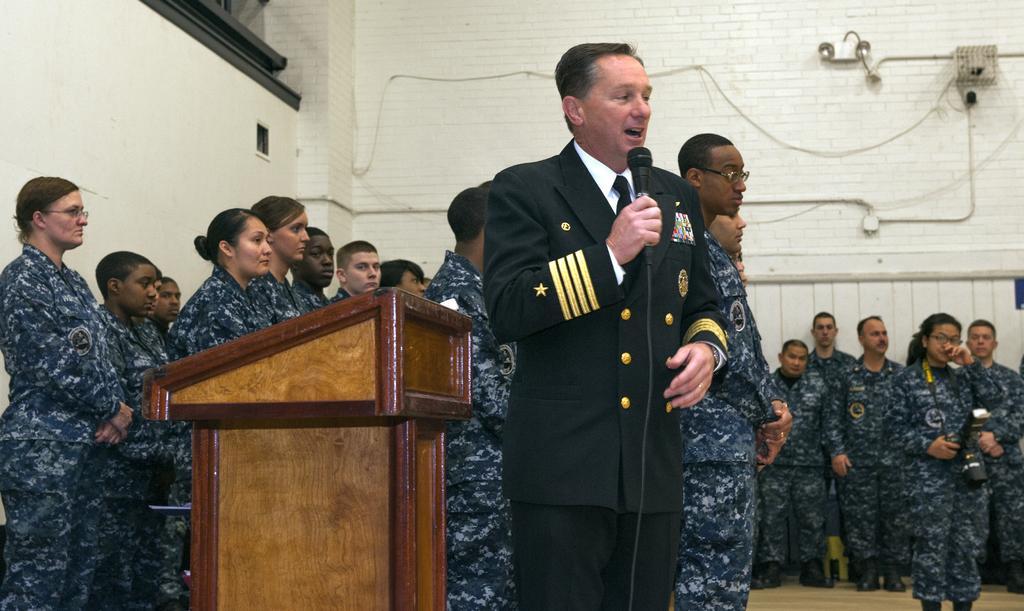Could you give a brief overview of what you see in this image? In the center of the image there is a person holding a mic in his hand. He is wearing a suit. In the background of the image there are many people wearing a uniform. There is a podium. In the background of the image there is a wall with wires. 